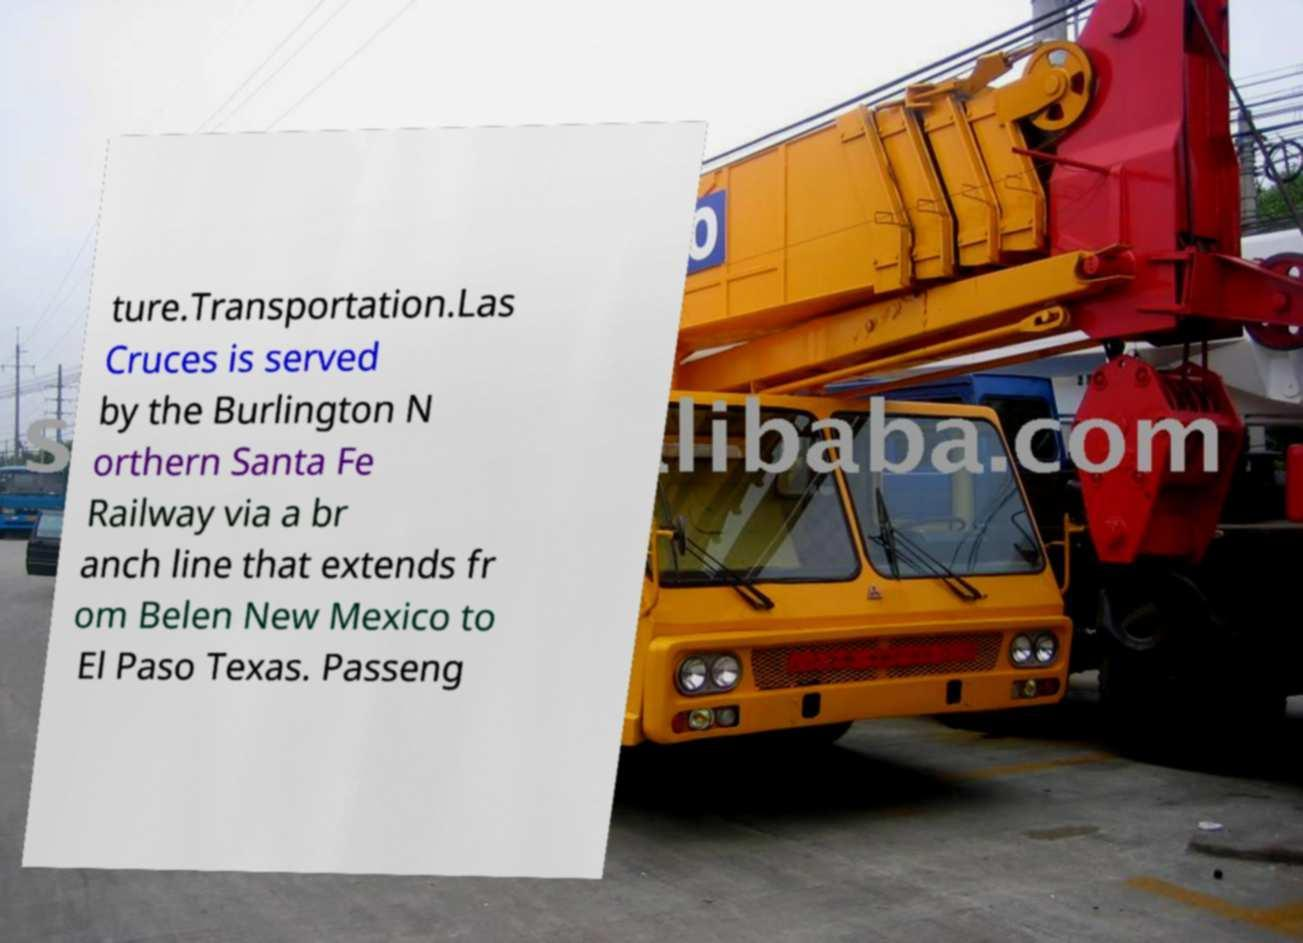I need the written content from this picture converted into text. Can you do that? ture.Transportation.Las Cruces is served by the Burlington N orthern Santa Fe Railway via a br anch line that extends fr om Belen New Mexico to El Paso Texas. Passeng 